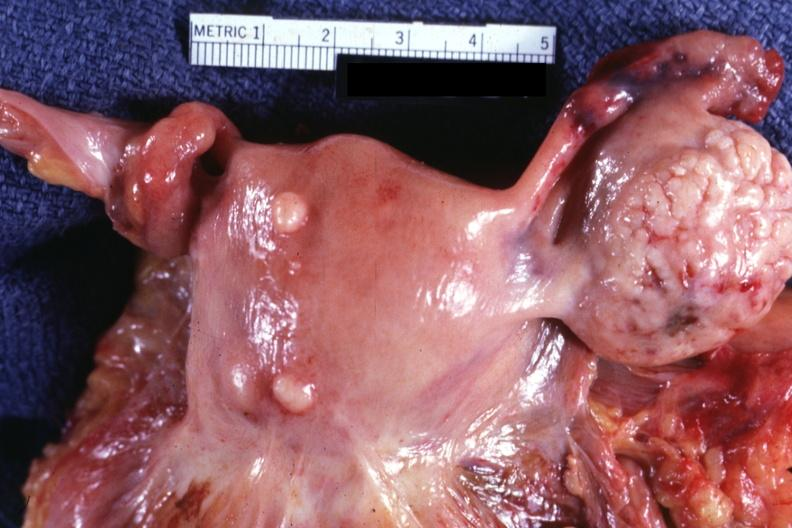re lymphoma small normal ovary is in photo?
Answer the question using a single word or phrase. No 